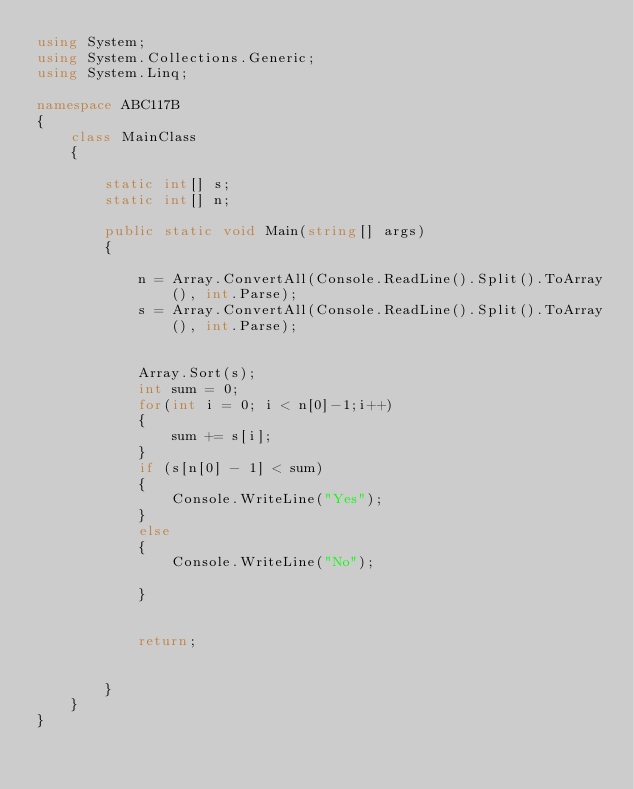Convert code to text. <code><loc_0><loc_0><loc_500><loc_500><_C#_>using System;
using System.Collections.Generic;
using System.Linq;

namespace ABC117B
{
    class MainClass
    {

        static int[] s;
        static int[] n;

        public static void Main(string[] args)
        {

            n = Array.ConvertAll(Console.ReadLine().Split().ToArray(), int.Parse);
            s = Array.ConvertAll(Console.ReadLine().Split().ToArray(), int.Parse);


            Array.Sort(s);
            int sum = 0;
            for(int i = 0; i < n[0]-1;i++)
            {
                sum += s[i];
            }
            if (s[n[0] - 1] < sum)
            {
                Console.WriteLine("Yes");
            }
            else
            {
                Console.WriteLine("No");

            }


            return;


        }
    }
}
</code> 